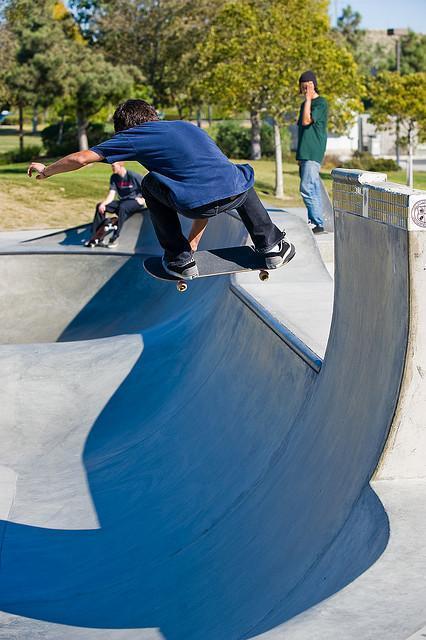How many skateboards can you see?
Give a very brief answer. 1. How many people are there?
Give a very brief answer. 3. How many birds do you see?
Give a very brief answer. 0. 